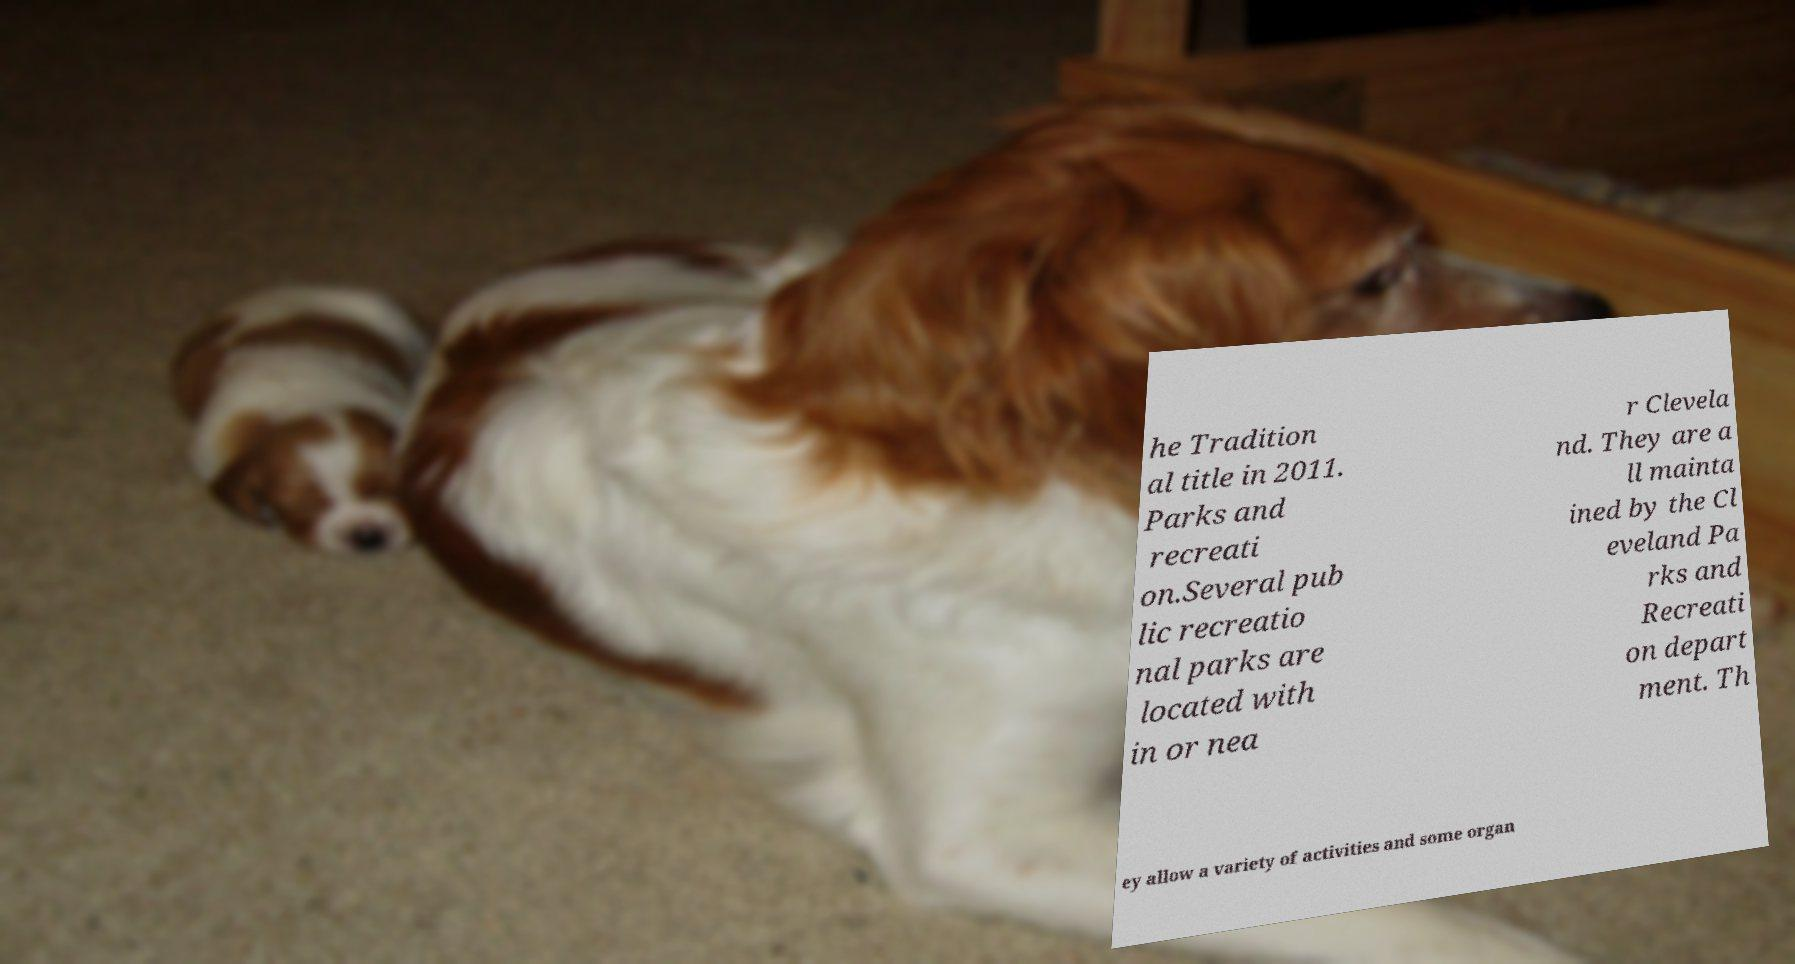There's text embedded in this image that I need extracted. Can you transcribe it verbatim? he Tradition al title in 2011. Parks and recreati on.Several pub lic recreatio nal parks are located with in or nea r Clevela nd. They are a ll mainta ined by the Cl eveland Pa rks and Recreati on depart ment. Th ey allow a variety of activities and some organ 